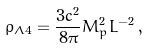Convert formula to latex. <formula><loc_0><loc_0><loc_500><loc_500>\rho _ { \Lambda 4 } = \frac { 3 c ^ { 2 } } { 8 \pi } M _ { p } ^ { 2 } L ^ { - 2 } \, ,</formula> 